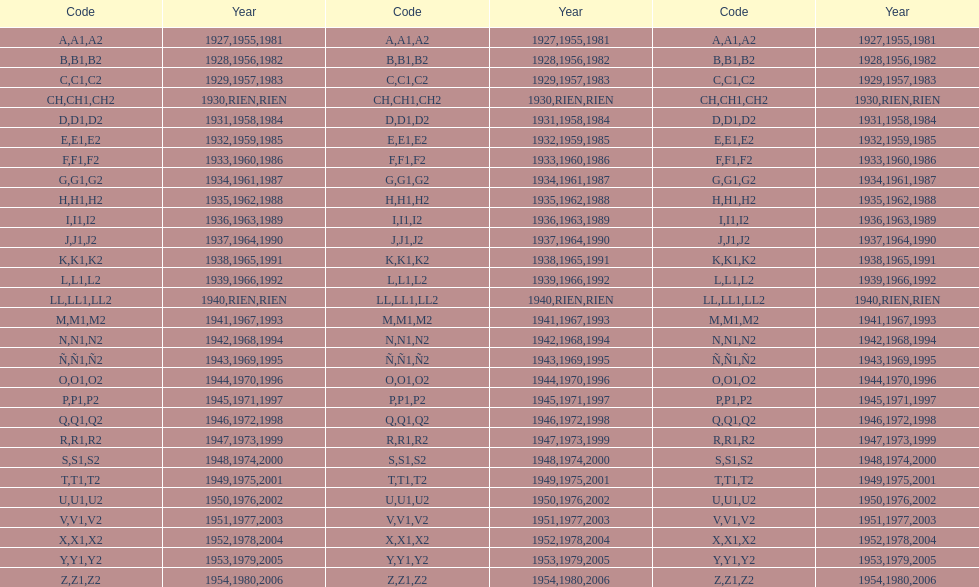What was the only year to use the code ch? 1930. 